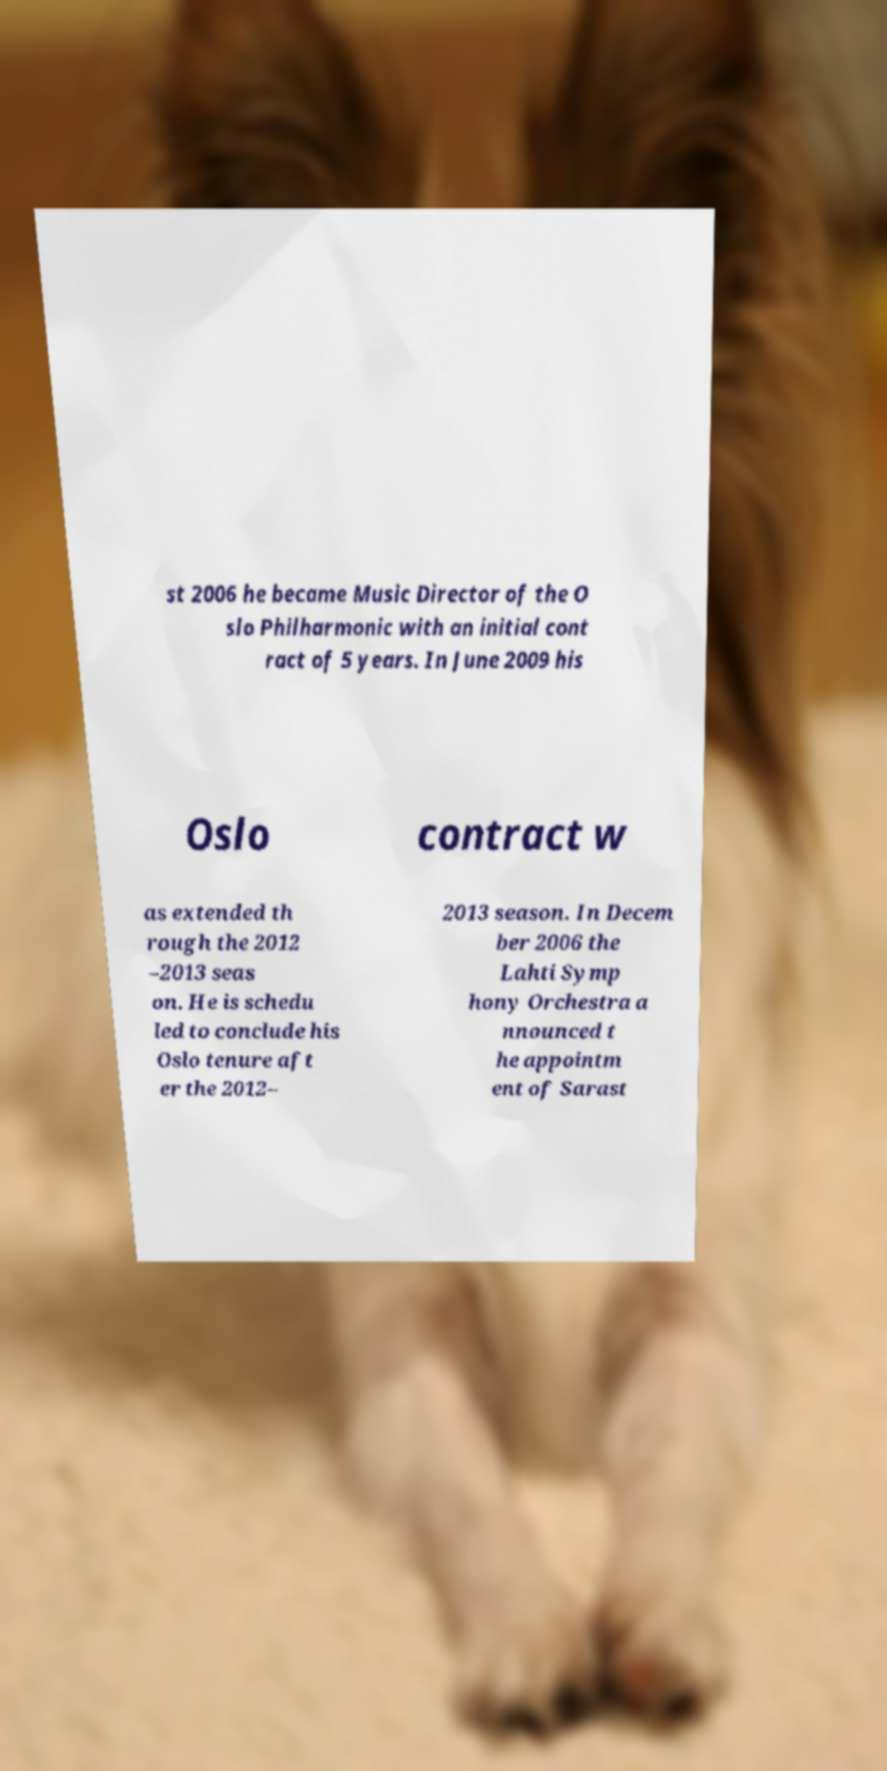There's text embedded in this image that I need extracted. Can you transcribe it verbatim? st 2006 he became Music Director of the O slo Philharmonic with an initial cont ract of 5 years. In June 2009 his Oslo contract w as extended th rough the 2012 –2013 seas on. He is schedu led to conclude his Oslo tenure aft er the 2012– 2013 season. In Decem ber 2006 the Lahti Symp hony Orchestra a nnounced t he appointm ent of Sarast 